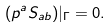<formula> <loc_0><loc_0><loc_500><loc_500>( p ^ { a } S _ { a b } ) | _ { \Gamma } = 0 .</formula> 